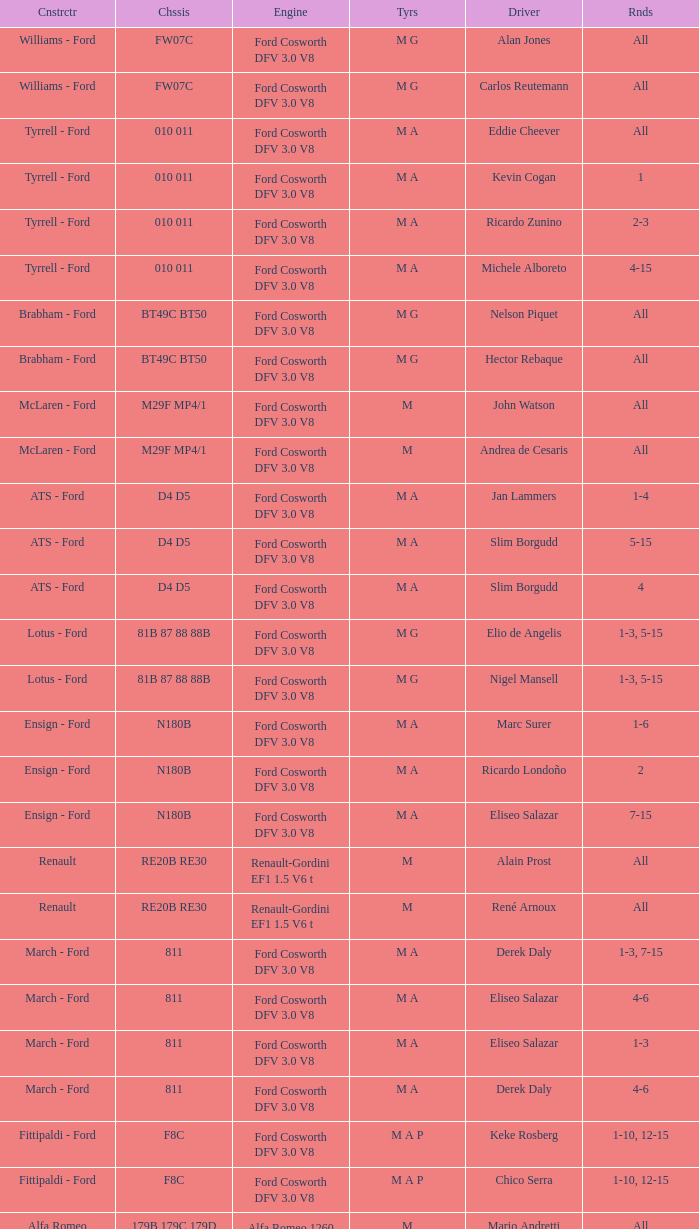Who constructed the car that Derek Warwick raced in with a TG181 chassis? Toleman - Hart. Could you parse the entire table? {'header': ['Cnstrctr', 'Chssis', 'Engine', 'Tyrs', 'Driver', 'Rnds'], 'rows': [['Williams - Ford', 'FW07C', 'Ford Cosworth DFV 3.0 V8', 'M G', 'Alan Jones', 'All'], ['Williams - Ford', 'FW07C', 'Ford Cosworth DFV 3.0 V8', 'M G', 'Carlos Reutemann', 'All'], ['Tyrrell - Ford', '010 011', 'Ford Cosworth DFV 3.0 V8', 'M A', 'Eddie Cheever', 'All'], ['Tyrrell - Ford', '010 011', 'Ford Cosworth DFV 3.0 V8', 'M A', 'Kevin Cogan', '1'], ['Tyrrell - Ford', '010 011', 'Ford Cosworth DFV 3.0 V8', 'M A', 'Ricardo Zunino', '2-3'], ['Tyrrell - Ford', '010 011', 'Ford Cosworth DFV 3.0 V8', 'M A', 'Michele Alboreto', '4-15'], ['Brabham - Ford', 'BT49C BT50', 'Ford Cosworth DFV 3.0 V8', 'M G', 'Nelson Piquet', 'All'], ['Brabham - Ford', 'BT49C BT50', 'Ford Cosworth DFV 3.0 V8', 'M G', 'Hector Rebaque', 'All'], ['McLaren - Ford', 'M29F MP4/1', 'Ford Cosworth DFV 3.0 V8', 'M', 'John Watson', 'All'], ['McLaren - Ford', 'M29F MP4/1', 'Ford Cosworth DFV 3.0 V8', 'M', 'Andrea de Cesaris', 'All'], ['ATS - Ford', 'D4 D5', 'Ford Cosworth DFV 3.0 V8', 'M A', 'Jan Lammers', '1-4'], ['ATS - Ford', 'D4 D5', 'Ford Cosworth DFV 3.0 V8', 'M A', 'Slim Borgudd', '5-15'], ['ATS - Ford', 'D4 D5', 'Ford Cosworth DFV 3.0 V8', 'M A', 'Slim Borgudd', '4'], ['Lotus - Ford', '81B 87 88 88B', 'Ford Cosworth DFV 3.0 V8', 'M G', 'Elio de Angelis', '1-3, 5-15'], ['Lotus - Ford', '81B 87 88 88B', 'Ford Cosworth DFV 3.0 V8', 'M G', 'Nigel Mansell', '1-3, 5-15'], ['Ensign - Ford', 'N180B', 'Ford Cosworth DFV 3.0 V8', 'M A', 'Marc Surer', '1-6'], ['Ensign - Ford', 'N180B', 'Ford Cosworth DFV 3.0 V8', 'M A', 'Ricardo Londoño', '2'], ['Ensign - Ford', 'N180B', 'Ford Cosworth DFV 3.0 V8', 'M A', 'Eliseo Salazar', '7-15'], ['Renault', 'RE20B RE30', 'Renault-Gordini EF1 1.5 V6 t', 'M', 'Alain Prost', 'All'], ['Renault', 'RE20B RE30', 'Renault-Gordini EF1 1.5 V6 t', 'M', 'René Arnoux', 'All'], ['March - Ford', '811', 'Ford Cosworth DFV 3.0 V8', 'M A', 'Derek Daly', '1-3, 7-15'], ['March - Ford', '811', 'Ford Cosworth DFV 3.0 V8', 'M A', 'Eliseo Salazar', '4-6'], ['March - Ford', '811', 'Ford Cosworth DFV 3.0 V8', 'M A', 'Eliseo Salazar', '1-3'], ['March - Ford', '811', 'Ford Cosworth DFV 3.0 V8', 'M A', 'Derek Daly', '4-6'], ['Fittipaldi - Ford', 'F8C', 'Ford Cosworth DFV 3.0 V8', 'M A P', 'Keke Rosberg', '1-10, 12-15'], ['Fittipaldi - Ford', 'F8C', 'Ford Cosworth DFV 3.0 V8', 'M A P', 'Chico Serra', '1-10, 12-15'], ['Alfa Romeo', '179B 179C 179D', 'Alfa Romeo 1260 3.0 V12', 'M', 'Mario Andretti', 'All'], ['Alfa Romeo', '179B 179C 179D', 'Alfa Romeo 1260 3.0 V12', 'M', 'Bruno Giacomelli', 'All'], ['Ligier - Matra', 'JS17', 'Matra MS81 3.0 V12', 'M', 'Jean-Pierre Jarier', '1-2'], ['Ligier - Matra', 'JS17', 'Matra MS81 3.0 V12', 'M', 'Jean-Pierre Jabouille', '3-7'], ['Ligier - Matra', 'JS17', 'Matra MS81 3.0 V12', 'M', 'Patrick Tambay', '8-15'], ['Ligier - Matra', 'JS17', 'Matra MS81 3.0 V12', 'M', 'Jacques Laffite', 'All'], ['Ferrari', '126CK', 'Ferrari 021 1.5 V6 t', 'M', 'Gilles Villeneuve', 'All'], ['Ferrari', '126CK', 'Ferrari 021 1.5 V6 t', 'M', 'Didier Pironi', 'All'], ['Arrows - Ford', 'A3', 'Ford Cosworth DFV 3.0 V8', 'M P', 'Riccardo Patrese', 'All'], ['Arrows - Ford', 'A3', 'Ford Cosworth DFV 3.0 V8', 'M P', 'Siegfried Stohr', '1-13'], ['Arrows - Ford', 'A3', 'Ford Cosworth DFV 3.0 V8', 'M P', 'Jacques Villeneuve, Sr.', '14-15'], ['Osella - Ford', 'FA1B FA1C', 'Ford Cosworth DFV 3.0 V8', 'M', 'Miguel Ángel Guerra', '1-4'], ['Osella - Ford', 'FA1B FA1C', 'Ford Cosworth DFV 3.0 V8', 'M', 'Piercarlo Ghinzani', '5'], ['Osella - Ford', 'FA1B FA1C', 'Ford Cosworth DFV 3.0 V8', 'M', 'Beppe Gabbiani', '6-15'], ['Osella - Ford', 'FA1B FA1C', 'Ford Cosworth DFV 3.0 V8', 'M', 'Beppe Gabbiani', '1-5'], ['Osella - Ford', 'FA1B FA1C', 'Ford Cosworth DFV 3.0 V8', 'M', 'Piercarlo Ghinzani', '6'], ['Osella - Ford', 'FA1B FA1C', 'Ford Cosworth DFV 3.0 V8', 'M', 'Giorgio Francia', '7'], ['Osella - Ford', 'FA1B FA1C', 'Ford Cosworth DFV 3.0 V8', 'M', 'Miguel Ángel Guerra', '8'], ['Osella - Ford', 'FA1B FA1C', 'Ford Cosworth DFV 3.0 V8', 'M', 'Jean-Pierre Jarier', '9-15'], ['Theodore - Ford', 'TY01', 'Ford Cosworth DFV 3.0 V8', 'M A', 'Patrick Tambay', '1-7'], ['Theodore - Ford', 'TY01', 'Ford Cosworth DFV 3.0 V8', 'M A', 'Marc Surer', '8-15'], ['Toleman - Hart', 'TG181', 'Hart 415T 1.5 L4 t', 'P', 'Brian Henton', '4-15'], ['Toleman - Hart', 'TG181', 'Hart 415T 1.5 L4 t', 'P', 'Derek Warwick', '4-15']]} 